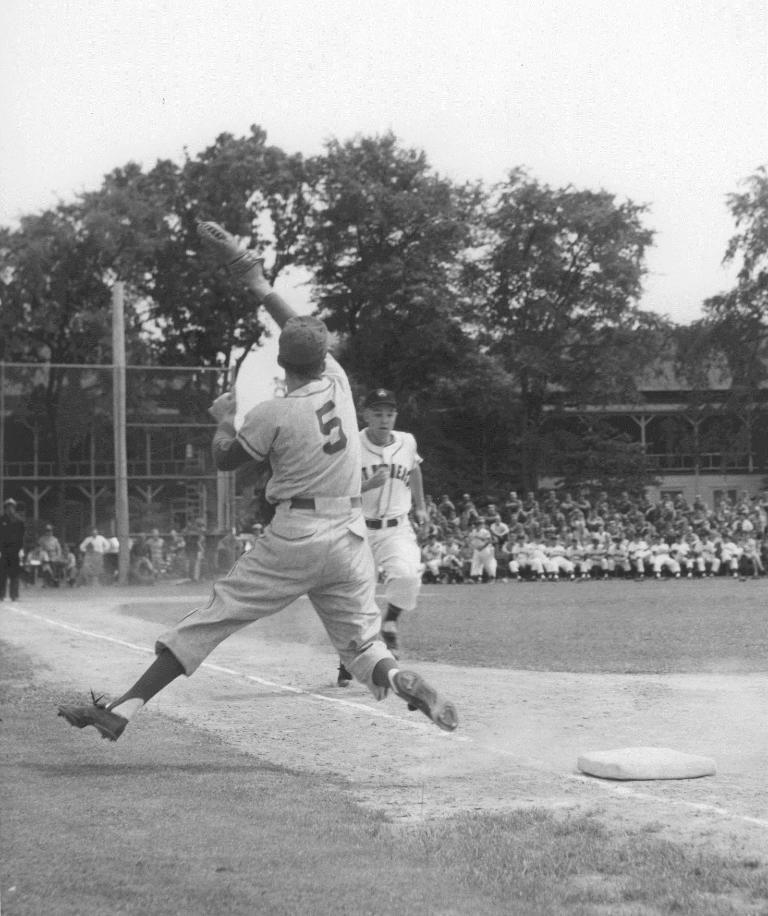Describe this image in one or two sentences. This is a black and white image. In the center of the image we can see two persons are playing. In the background of the image we can see a group of people, pole, mesh, building, trees. At the top of the image we can see the sky. At the bottom of the image we can see the ground and object. 